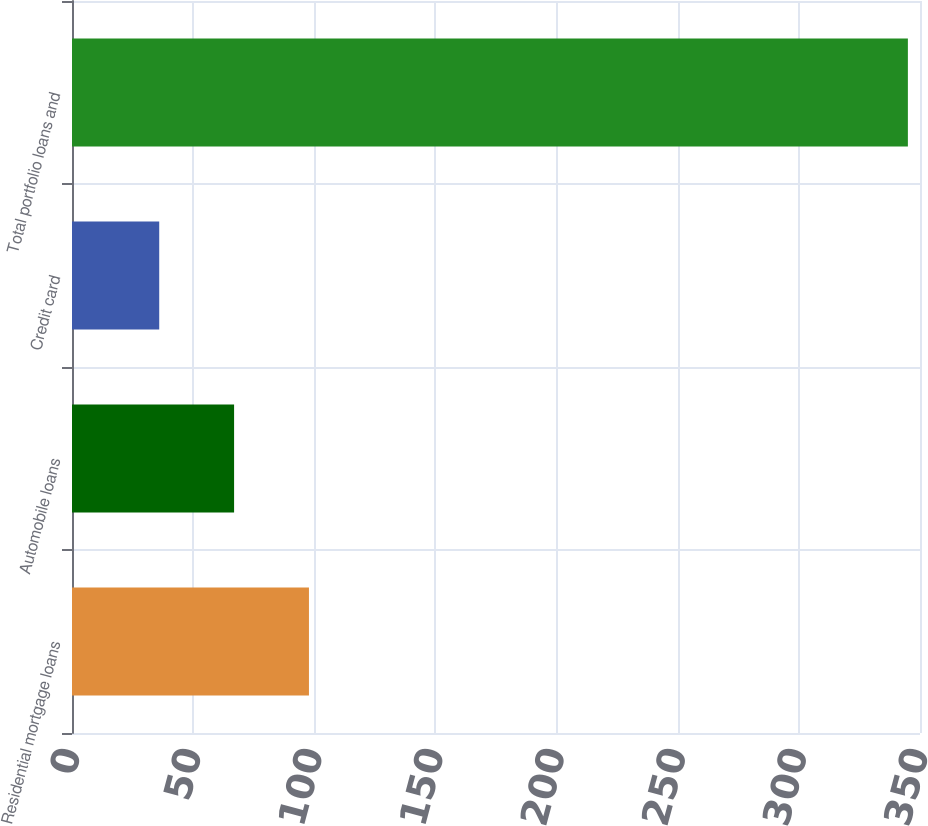Convert chart. <chart><loc_0><loc_0><loc_500><loc_500><bar_chart><fcel>Residential mortgage loans<fcel>Automobile loans<fcel>Credit card<fcel>Total portfolio loans and<nl><fcel>97.8<fcel>66.9<fcel>36<fcel>345<nl></chart> 